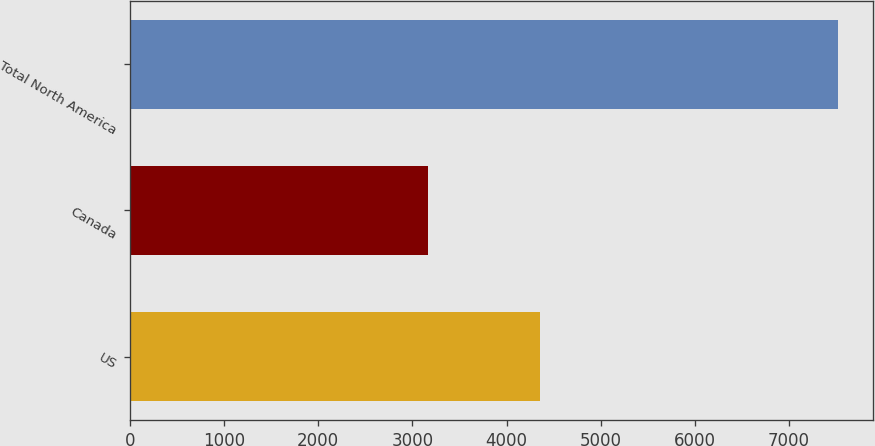Convert chart to OTSL. <chart><loc_0><loc_0><loc_500><loc_500><bar_chart><fcel>US<fcel>Canada<fcel>Total North America<nl><fcel>4352<fcel>3166<fcel>7518<nl></chart> 